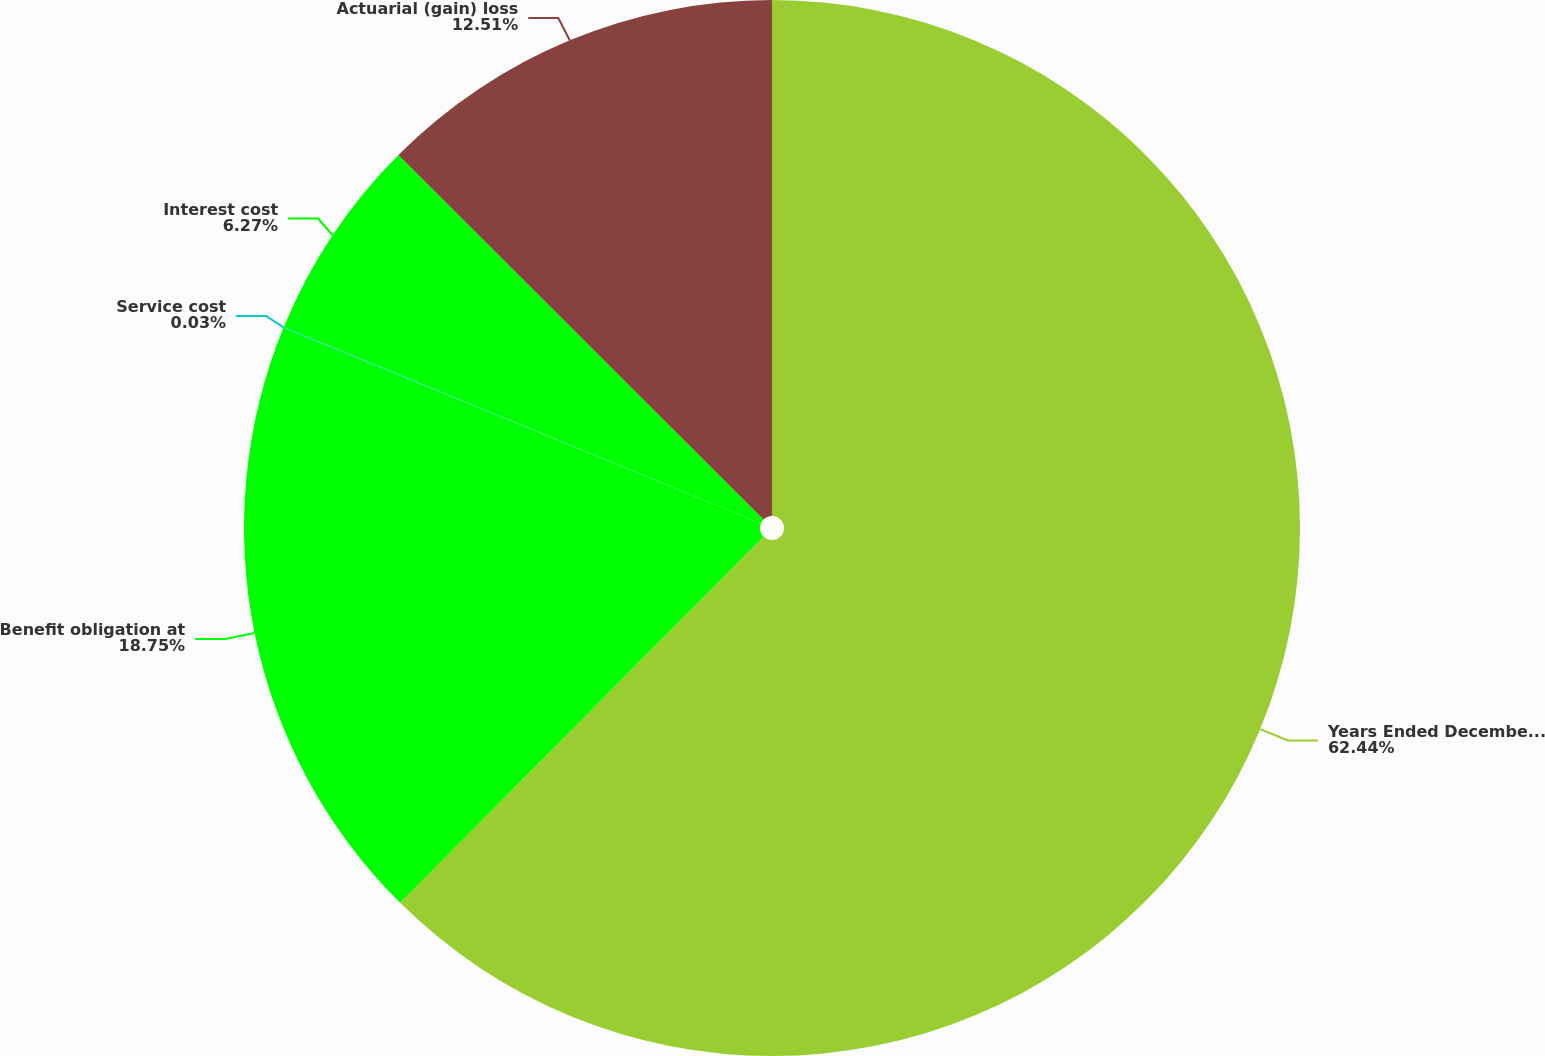Convert chart. <chart><loc_0><loc_0><loc_500><loc_500><pie_chart><fcel>Years Ended December 31<fcel>Benefit obligation at<fcel>Service cost<fcel>Interest cost<fcel>Actuarial (gain) loss<nl><fcel>62.43%<fcel>18.75%<fcel>0.03%<fcel>6.27%<fcel>12.51%<nl></chart> 